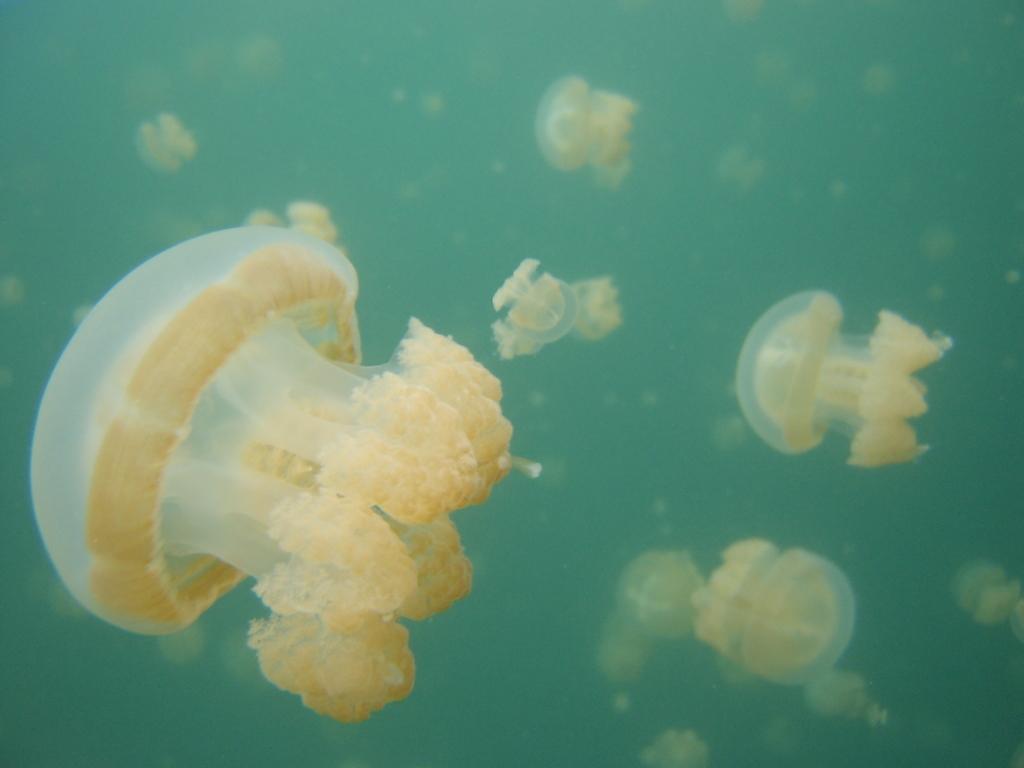How would you summarize this image in a sentence or two? In this picture we can see jellyfish in the water. 